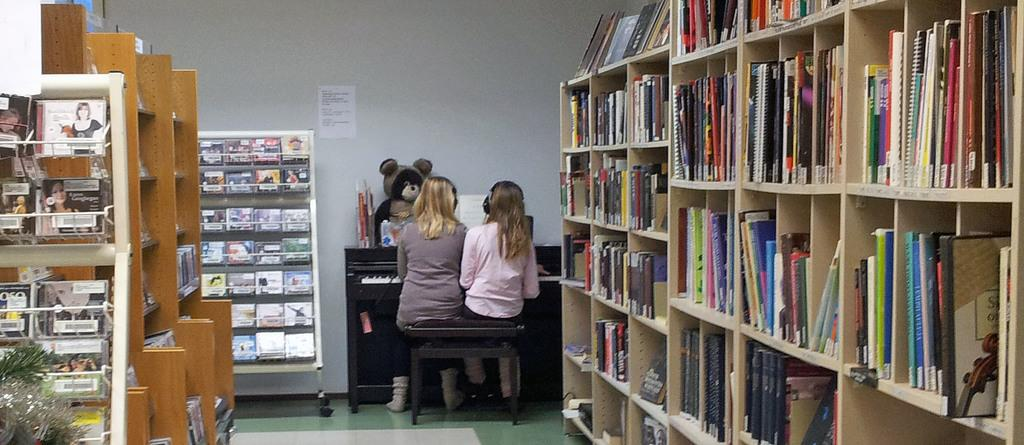What type of items can be seen in the racks in the image? There are books in racks in the image. How many people are sitting on a stool in the image? There are two people sitting on a stool in the image. What musical instrument is present in the image? There is a piano in the image. What type of toy can be seen in the image? There is a teddy bear in the image. What type of writing material is present in the image? There are papers in the image. What type of living organism is present in the image? There is a plant in the image. What type of decoration is present on the wall in the image? There is a poster on the wall in the image. What other objects can be seen in the racks in the image? There are some objects in the racks in the image. What type of competition is taking place in the image? There is no competition present in the image. Can you see a rat in the image? There is no rat present in the image. What type of nut is being used as a decoration in the image? There is no nut present in the image. 